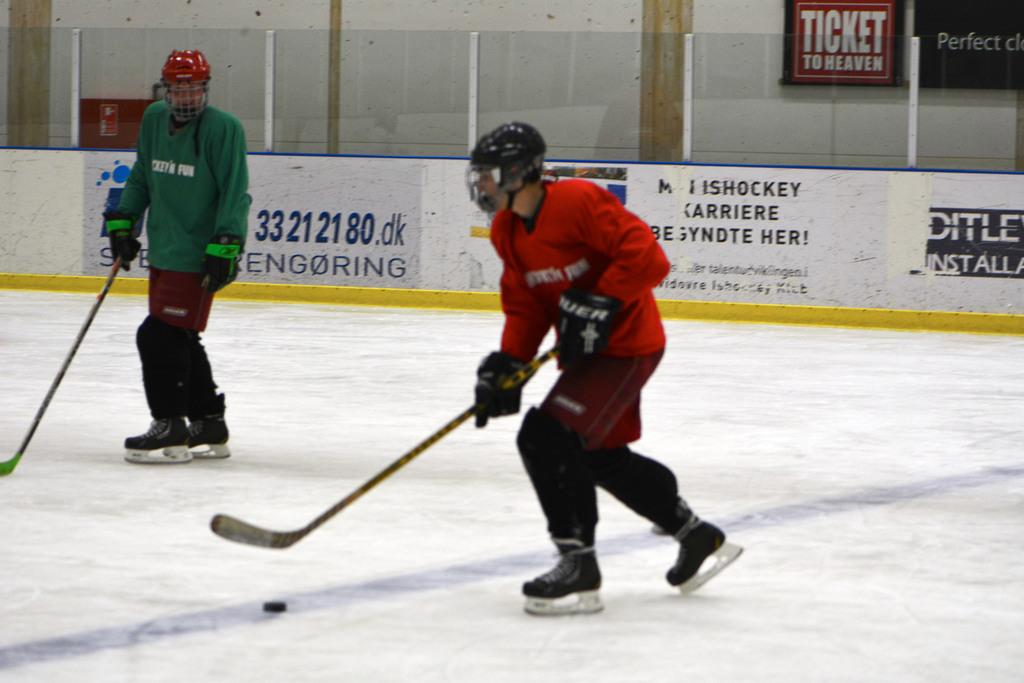What game is being played?
Give a very brief answer. Answering does not require reading text in the image. What is written on the sign in the backgroun?
Offer a terse response. Ticket to heaven. 